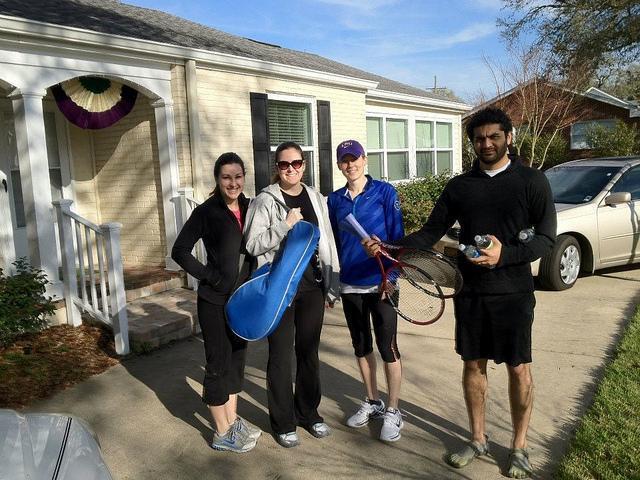How many cars are visible?
Give a very brief answer. 2. How many tennis rackets are there?
Give a very brief answer. 2. How many people are there?
Give a very brief answer. 4. 